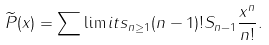Convert formula to latex. <formula><loc_0><loc_0><loc_500><loc_500>\widetilde { P } ( x ) = \sum \lim i t s _ { n \geq 1 } ( n - 1 ) ! S _ { n - 1 } \frac { x ^ { n } } { n ! } .</formula> 